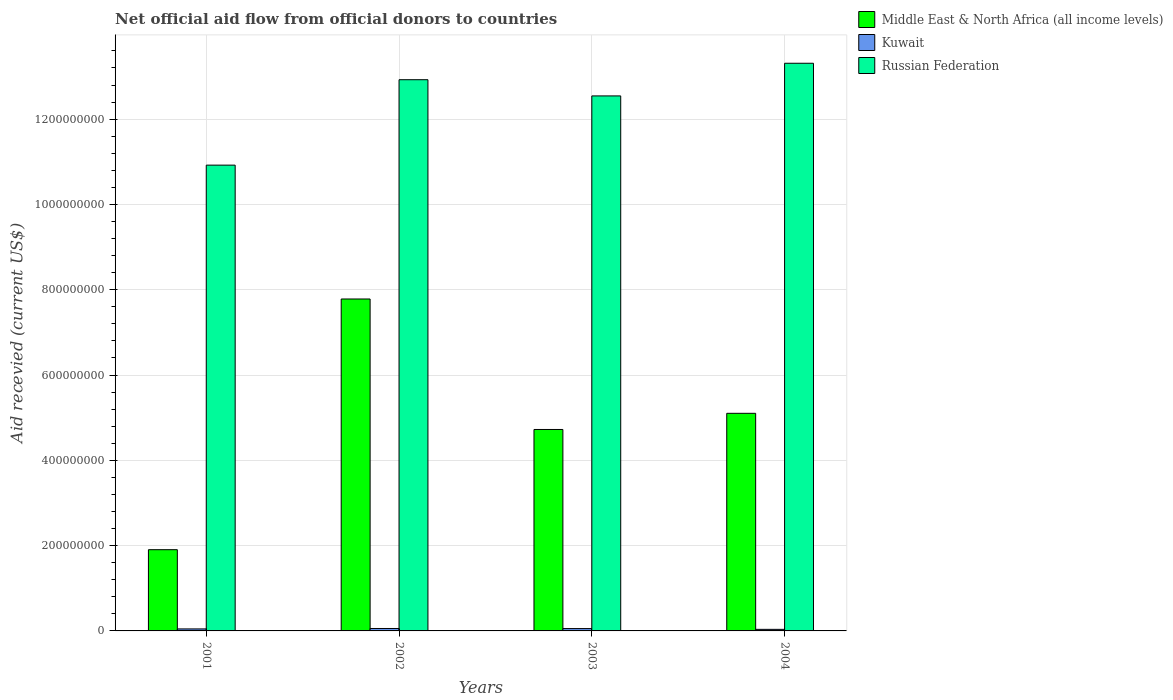How many different coloured bars are there?
Keep it short and to the point. 3. How many groups of bars are there?
Your response must be concise. 4. Are the number of bars per tick equal to the number of legend labels?
Provide a succinct answer. Yes. How many bars are there on the 3rd tick from the right?
Provide a short and direct response. 3. In how many cases, is the number of bars for a given year not equal to the number of legend labels?
Your response must be concise. 0. What is the total aid received in Middle East & North Africa (all income levels) in 2003?
Give a very brief answer. 4.72e+08. Across all years, what is the maximum total aid received in Kuwait?
Make the answer very short. 5.71e+06. Across all years, what is the minimum total aid received in Kuwait?
Provide a short and direct response. 3.69e+06. In which year was the total aid received in Middle East & North Africa (all income levels) maximum?
Make the answer very short. 2002. What is the total total aid received in Russian Federation in the graph?
Ensure brevity in your answer.  4.97e+09. What is the difference between the total aid received in Kuwait in 2002 and that in 2003?
Keep it short and to the point. 1.90e+05. What is the difference between the total aid received in Kuwait in 2003 and the total aid received in Russian Federation in 2002?
Make the answer very short. -1.29e+09. What is the average total aid received in Middle East & North Africa (all income levels) per year?
Your answer should be very brief. 4.88e+08. In the year 2003, what is the difference between the total aid received in Middle East & North Africa (all income levels) and total aid received in Kuwait?
Offer a very short reply. 4.67e+08. What is the ratio of the total aid received in Russian Federation in 2002 to that in 2003?
Ensure brevity in your answer.  1.03. Is the difference between the total aid received in Middle East & North Africa (all income levels) in 2001 and 2004 greater than the difference between the total aid received in Kuwait in 2001 and 2004?
Provide a short and direct response. No. What is the difference between the highest and the second highest total aid received in Russian Federation?
Provide a short and direct response. 3.86e+07. What is the difference between the highest and the lowest total aid received in Middle East & North Africa (all income levels)?
Your answer should be very brief. 5.88e+08. Is the sum of the total aid received in Russian Federation in 2003 and 2004 greater than the maximum total aid received in Middle East & North Africa (all income levels) across all years?
Provide a short and direct response. Yes. What does the 1st bar from the left in 2004 represents?
Your answer should be compact. Middle East & North Africa (all income levels). What does the 2nd bar from the right in 2004 represents?
Your answer should be compact. Kuwait. Is it the case that in every year, the sum of the total aid received in Middle East & North Africa (all income levels) and total aid received in Kuwait is greater than the total aid received in Russian Federation?
Provide a succinct answer. No. Are all the bars in the graph horizontal?
Offer a terse response. No. What is the difference between two consecutive major ticks on the Y-axis?
Offer a terse response. 2.00e+08. Does the graph contain grids?
Offer a very short reply. Yes. How many legend labels are there?
Make the answer very short. 3. How are the legend labels stacked?
Make the answer very short. Vertical. What is the title of the graph?
Ensure brevity in your answer.  Net official aid flow from official donors to countries. What is the label or title of the Y-axis?
Make the answer very short. Aid recevied (current US$). What is the Aid recevied (current US$) of Middle East & North Africa (all income levels) in 2001?
Keep it short and to the point. 1.90e+08. What is the Aid recevied (current US$) in Kuwait in 2001?
Offer a terse response. 4.69e+06. What is the Aid recevied (current US$) of Russian Federation in 2001?
Give a very brief answer. 1.09e+09. What is the Aid recevied (current US$) of Middle East & North Africa (all income levels) in 2002?
Provide a succinct answer. 7.78e+08. What is the Aid recevied (current US$) of Kuwait in 2002?
Offer a very short reply. 5.71e+06. What is the Aid recevied (current US$) in Russian Federation in 2002?
Make the answer very short. 1.29e+09. What is the Aid recevied (current US$) in Middle East & North Africa (all income levels) in 2003?
Keep it short and to the point. 4.72e+08. What is the Aid recevied (current US$) of Kuwait in 2003?
Offer a very short reply. 5.52e+06. What is the Aid recevied (current US$) of Russian Federation in 2003?
Offer a very short reply. 1.25e+09. What is the Aid recevied (current US$) in Middle East & North Africa (all income levels) in 2004?
Give a very brief answer. 5.10e+08. What is the Aid recevied (current US$) of Kuwait in 2004?
Keep it short and to the point. 3.69e+06. What is the Aid recevied (current US$) in Russian Federation in 2004?
Your answer should be compact. 1.33e+09. Across all years, what is the maximum Aid recevied (current US$) of Middle East & North Africa (all income levels)?
Ensure brevity in your answer.  7.78e+08. Across all years, what is the maximum Aid recevied (current US$) in Kuwait?
Offer a terse response. 5.71e+06. Across all years, what is the maximum Aid recevied (current US$) in Russian Federation?
Provide a short and direct response. 1.33e+09. Across all years, what is the minimum Aid recevied (current US$) in Middle East & North Africa (all income levels)?
Your response must be concise. 1.90e+08. Across all years, what is the minimum Aid recevied (current US$) of Kuwait?
Offer a terse response. 3.69e+06. Across all years, what is the minimum Aid recevied (current US$) of Russian Federation?
Keep it short and to the point. 1.09e+09. What is the total Aid recevied (current US$) in Middle East & North Africa (all income levels) in the graph?
Your answer should be very brief. 1.95e+09. What is the total Aid recevied (current US$) in Kuwait in the graph?
Your answer should be very brief. 1.96e+07. What is the total Aid recevied (current US$) of Russian Federation in the graph?
Make the answer very short. 4.97e+09. What is the difference between the Aid recevied (current US$) in Middle East & North Africa (all income levels) in 2001 and that in 2002?
Ensure brevity in your answer.  -5.88e+08. What is the difference between the Aid recevied (current US$) of Kuwait in 2001 and that in 2002?
Ensure brevity in your answer.  -1.02e+06. What is the difference between the Aid recevied (current US$) of Russian Federation in 2001 and that in 2002?
Your answer should be very brief. -2.00e+08. What is the difference between the Aid recevied (current US$) in Middle East & North Africa (all income levels) in 2001 and that in 2003?
Provide a short and direct response. -2.82e+08. What is the difference between the Aid recevied (current US$) in Kuwait in 2001 and that in 2003?
Offer a terse response. -8.30e+05. What is the difference between the Aid recevied (current US$) of Russian Federation in 2001 and that in 2003?
Give a very brief answer. -1.62e+08. What is the difference between the Aid recevied (current US$) in Middle East & North Africa (all income levels) in 2001 and that in 2004?
Offer a terse response. -3.20e+08. What is the difference between the Aid recevied (current US$) of Russian Federation in 2001 and that in 2004?
Keep it short and to the point. -2.39e+08. What is the difference between the Aid recevied (current US$) of Middle East & North Africa (all income levels) in 2002 and that in 2003?
Your answer should be very brief. 3.06e+08. What is the difference between the Aid recevied (current US$) in Kuwait in 2002 and that in 2003?
Your response must be concise. 1.90e+05. What is the difference between the Aid recevied (current US$) in Russian Federation in 2002 and that in 2003?
Provide a succinct answer. 3.80e+07. What is the difference between the Aid recevied (current US$) in Middle East & North Africa (all income levels) in 2002 and that in 2004?
Give a very brief answer. 2.68e+08. What is the difference between the Aid recevied (current US$) in Kuwait in 2002 and that in 2004?
Your response must be concise. 2.02e+06. What is the difference between the Aid recevied (current US$) in Russian Federation in 2002 and that in 2004?
Your response must be concise. -3.86e+07. What is the difference between the Aid recevied (current US$) in Middle East & North Africa (all income levels) in 2003 and that in 2004?
Your answer should be compact. -3.79e+07. What is the difference between the Aid recevied (current US$) of Kuwait in 2003 and that in 2004?
Keep it short and to the point. 1.83e+06. What is the difference between the Aid recevied (current US$) in Russian Federation in 2003 and that in 2004?
Provide a short and direct response. -7.66e+07. What is the difference between the Aid recevied (current US$) in Middle East & North Africa (all income levels) in 2001 and the Aid recevied (current US$) in Kuwait in 2002?
Offer a terse response. 1.85e+08. What is the difference between the Aid recevied (current US$) in Middle East & North Africa (all income levels) in 2001 and the Aid recevied (current US$) in Russian Federation in 2002?
Provide a short and direct response. -1.10e+09. What is the difference between the Aid recevied (current US$) of Kuwait in 2001 and the Aid recevied (current US$) of Russian Federation in 2002?
Make the answer very short. -1.29e+09. What is the difference between the Aid recevied (current US$) of Middle East & North Africa (all income levels) in 2001 and the Aid recevied (current US$) of Kuwait in 2003?
Ensure brevity in your answer.  1.85e+08. What is the difference between the Aid recevied (current US$) in Middle East & North Africa (all income levels) in 2001 and the Aid recevied (current US$) in Russian Federation in 2003?
Offer a very short reply. -1.06e+09. What is the difference between the Aid recevied (current US$) of Kuwait in 2001 and the Aid recevied (current US$) of Russian Federation in 2003?
Provide a short and direct response. -1.25e+09. What is the difference between the Aid recevied (current US$) in Middle East & North Africa (all income levels) in 2001 and the Aid recevied (current US$) in Kuwait in 2004?
Your answer should be very brief. 1.87e+08. What is the difference between the Aid recevied (current US$) in Middle East & North Africa (all income levels) in 2001 and the Aid recevied (current US$) in Russian Federation in 2004?
Provide a short and direct response. -1.14e+09. What is the difference between the Aid recevied (current US$) of Kuwait in 2001 and the Aid recevied (current US$) of Russian Federation in 2004?
Your answer should be compact. -1.33e+09. What is the difference between the Aid recevied (current US$) in Middle East & North Africa (all income levels) in 2002 and the Aid recevied (current US$) in Kuwait in 2003?
Provide a succinct answer. 7.73e+08. What is the difference between the Aid recevied (current US$) in Middle East & North Africa (all income levels) in 2002 and the Aid recevied (current US$) in Russian Federation in 2003?
Your answer should be compact. -4.76e+08. What is the difference between the Aid recevied (current US$) in Kuwait in 2002 and the Aid recevied (current US$) in Russian Federation in 2003?
Your answer should be very brief. -1.25e+09. What is the difference between the Aid recevied (current US$) in Middle East & North Africa (all income levels) in 2002 and the Aid recevied (current US$) in Kuwait in 2004?
Provide a succinct answer. 7.75e+08. What is the difference between the Aid recevied (current US$) in Middle East & North Africa (all income levels) in 2002 and the Aid recevied (current US$) in Russian Federation in 2004?
Provide a succinct answer. -5.53e+08. What is the difference between the Aid recevied (current US$) in Kuwait in 2002 and the Aid recevied (current US$) in Russian Federation in 2004?
Your answer should be very brief. -1.33e+09. What is the difference between the Aid recevied (current US$) in Middle East & North Africa (all income levels) in 2003 and the Aid recevied (current US$) in Kuwait in 2004?
Provide a succinct answer. 4.69e+08. What is the difference between the Aid recevied (current US$) of Middle East & North Africa (all income levels) in 2003 and the Aid recevied (current US$) of Russian Federation in 2004?
Ensure brevity in your answer.  -8.59e+08. What is the difference between the Aid recevied (current US$) of Kuwait in 2003 and the Aid recevied (current US$) of Russian Federation in 2004?
Make the answer very short. -1.33e+09. What is the average Aid recevied (current US$) of Middle East & North Africa (all income levels) per year?
Your response must be concise. 4.88e+08. What is the average Aid recevied (current US$) in Kuwait per year?
Ensure brevity in your answer.  4.90e+06. What is the average Aid recevied (current US$) of Russian Federation per year?
Your answer should be compact. 1.24e+09. In the year 2001, what is the difference between the Aid recevied (current US$) of Middle East & North Africa (all income levels) and Aid recevied (current US$) of Kuwait?
Your response must be concise. 1.86e+08. In the year 2001, what is the difference between the Aid recevied (current US$) of Middle East & North Africa (all income levels) and Aid recevied (current US$) of Russian Federation?
Ensure brevity in your answer.  -9.02e+08. In the year 2001, what is the difference between the Aid recevied (current US$) in Kuwait and Aid recevied (current US$) in Russian Federation?
Provide a short and direct response. -1.09e+09. In the year 2002, what is the difference between the Aid recevied (current US$) of Middle East & North Africa (all income levels) and Aid recevied (current US$) of Kuwait?
Offer a terse response. 7.73e+08. In the year 2002, what is the difference between the Aid recevied (current US$) of Middle East & North Africa (all income levels) and Aid recevied (current US$) of Russian Federation?
Offer a very short reply. -5.14e+08. In the year 2002, what is the difference between the Aid recevied (current US$) in Kuwait and Aid recevied (current US$) in Russian Federation?
Your answer should be compact. -1.29e+09. In the year 2003, what is the difference between the Aid recevied (current US$) of Middle East & North Africa (all income levels) and Aid recevied (current US$) of Kuwait?
Provide a short and direct response. 4.67e+08. In the year 2003, what is the difference between the Aid recevied (current US$) in Middle East & North Africa (all income levels) and Aid recevied (current US$) in Russian Federation?
Your response must be concise. -7.82e+08. In the year 2003, what is the difference between the Aid recevied (current US$) of Kuwait and Aid recevied (current US$) of Russian Federation?
Keep it short and to the point. -1.25e+09. In the year 2004, what is the difference between the Aid recevied (current US$) of Middle East & North Africa (all income levels) and Aid recevied (current US$) of Kuwait?
Keep it short and to the point. 5.07e+08. In the year 2004, what is the difference between the Aid recevied (current US$) of Middle East & North Africa (all income levels) and Aid recevied (current US$) of Russian Federation?
Your response must be concise. -8.21e+08. In the year 2004, what is the difference between the Aid recevied (current US$) in Kuwait and Aid recevied (current US$) in Russian Federation?
Offer a terse response. -1.33e+09. What is the ratio of the Aid recevied (current US$) in Middle East & North Africa (all income levels) in 2001 to that in 2002?
Ensure brevity in your answer.  0.24. What is the ratio of the Aid recevied (current US$) of Kuwait in 2001 to that in 2002?
Provide a succinct answer. 0.82. What is the ratio of the Aid recevied (current US$) in Russian Federation in 2001 to that in 2002?
Give a very brief answer. 0.84. What is the ratio of the Aid recevied (current US$) in Middle East & North Africa (all income levels) in 2001 to that in 2003?
Your answer should be compact. 0.4. What is the ratio of the Aid recevied (current US$) of Kuwait in 2001 to that in 2003?
Keep it short and to the point. 0.85. What is the ratio of the Aid recevied (current US$) in Russian Federation in 2001 to that in 2003?
Make the answer very short. 0.87. What is the ratio of the Aid recevied (current US$) in Middle East & North Africa (all income levels) in 2001 to that in 2004?
Keep it short and to the point. 0.37. What is the ratio of the Aid recevied (current US$) of Kuwait in 2001 to that in 2004?
Provide a short and direct response. 1.27. What is the ratio of the Aid recevied (current US$) of Russian Federation in 2001 to that in 2004?
Offer a terse response. 0.82. What is the ratio of the Aid recevied (current US$) of Middle East & North Africa (all income levels) in 2002 to that in 2003?
Your answer should be very brief. 1.65. What is the ratio of the Aid recevied (current US$) of Kuwait in 2002 to that in 2003?
Make the answer very short. 1.03. What is the ratio of the Aid recevied (current US$) in Russian Federation in 2002 to that in 2003?
Give a very brief answer. 1.03. What is the ratio of the Aid recevied (current US$) of Middle East & North Africa (all income levels) in 2002 to that in 2004?
Provide a succinct answer. 1.53. What is the ratio of the Aid recevied (current US$) of Kuwait in 2002 to that in 2004?
Make the answer very short. 1.55. What is the ratio of the Aid recevied (current US$) in Middle East & North Africa (all income levels) in 2003 to that in 2004?
Your answer should be very brief. 0.93. What is the ratio of the Aid recevied (current US$) in Kuwait in 2003 to that in 2004?
Offer a terse response. 1.5. What is the ratio of the Aid recevied (current US$) of Russian Federation in 2003 to that in 2004?
Offer a terse response. 0.94. What is the difference between the highest and the second highest Aid recevied (current US$) in Middle East & North Africa (all income levels)?
Offer a terse response. 2.68e+08. What is the difference between the highest and the second highest Aid recevied (current US$) in Kuwait?
Make the answer very short. 1.90e+05. What is the difference between the highest and the second highest Aid recevied (current US$) of Russian Federation?
Ensure brevity in your answer.  3.86e+07. What is the difference between the highest and the lowest Aid recevied (current US$) in Middle East & North Africa (all income levels)?
Offer a terse response. 5.88e+08. What is the difference between the highest and the lowest Aid recevied (current US$) of Kuwait?
Offer a terse response. 2.02e+06. What is the difference between the highest and the lowest Aid recevied (current US$) of Russian Federation?
Your answer should be compact. 2.39e+08. 